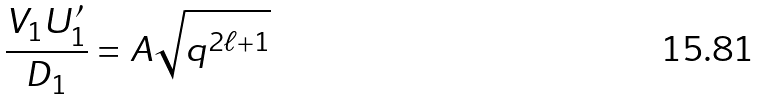<formula> <loc_0><loc_0><loc_500><loc_500>\frac { V _ { 1 } U ^ { \prime } _ { 1 } } { D _ { 1 } } = A \sqrt { q ^ { 2 \ell + 1 } }</formula> 